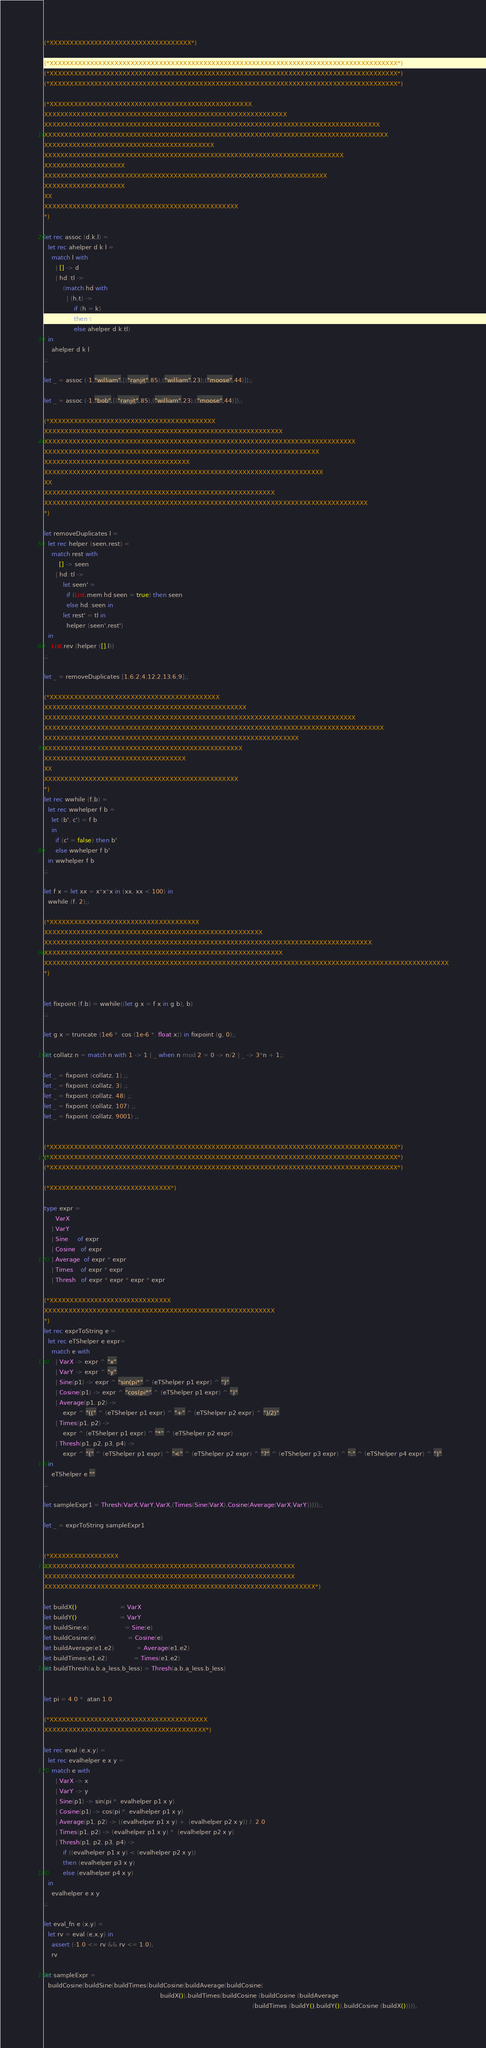Convert code to text. <code><loc_0><loc_0><loc_500><loc_500><_OCaml_>(*XXXXXXXXXXXXXXXXXXXXXXXXXXXXXXXXXXX*)

(*XXXXXXXXXXXXXXXXXXXXXXXXXXXXXXXXXXXXXXXXXXXXXXXXXXXXXXXXXXXXXXXXXXXXXXXXXXXXXXXXXXXXXX*)
(*XXXXXXXXXXXXXXXXXXXXXXXXXXXXXXXXXXXXXXXXXXXXXXXXXXXXXXXXXXXXXXXXXXXXXXXXXXXXXXXXXXXXXX*)
(*XXXXXXXXXXXXXXXXXXXXXXXXXXXXXXXXXXXXXXXXXXXXXXXXXXXXXXXXXXXXXXXXXXXXXXXXXXXXXXXXXXXXXX*)

(*XXXXXXXXXXXXXXXXXXXXXXXXXXXXXXXXXXXXXXXXXXXXXXXXXX
XXXXXXXXXXXXXXXXXXXXXXXXXXXXXXXXXXXXXXXXXXXXXXXXXXXXXXXXXXXX
XXXXXXXXXXXXXXXXXXXXXXXXXXXXXXXXXXXXXXXXXXXXXXXXXXXXXXXXXXXXXXXXXXXXXXXXXXXXXXXXXXX
XXXXXXXXXXXXXXXXXXXXXXXXXXXXXXXXXXXXXXXXXXXXXXXXXXXXXXXXXXXXXXXXXXXXXXXXXXXXXXXXXXXXX
XXXXXXXXXXXXXXXXXXXXXXXXXXXXXXXXXXXXXXXXXX
XXXXXXXXXXXXXXXXXXXXXXXXXXXXXXXXXXXXXXXXXXXXXXXXXXXXXXXXXXXXXXXXXXXXXXXXXX
XXXXXXXXXXXXXXXXXXXX
XXXXXXXXXXXXXXXXXXXXXXXXXXXXXXXXXXXXXXXXXXXXXXXXXXXXXXXXXXXXXXXXXXXXXX
XXXXXXXXXXXXXXXXXXXX
XX
XXXXXXXXXXXXXXXXXXXXXXXXXXXXXXXXXXXXXXXXXXXXXXXX
*)

let rec assoc (d,k,l) =
  let rec ahelper d k l = 
    match l with
      | [] -> d
      | hd::tl ->
          (match hd with
            | (h,t) ->
                if (h = k)
                then t
                else ahelper d k tl)
  in
    ahelper d k l
;;

let _ = assoc (-1,"william",[("ranjit",85);("william",23);("moose",44)]);;    

let _ = assoc (-1,"bob",[("ranjit",85);("william",23);("moose",44)]);;

(*XXXXXXXXXXXXXXXXXXXXXXXXXXXXXXXXXXXXXXXXX
XXXXXXXXXXXXXXXXXXXXXXXXXXXXXXXXXXXXXXXXXXXXXXXXXXXXXXXXXXX
XXXXXXXXXXXXXXXXXXXXXXXXXXXXXXXXXXXXXXXXXXXXXXXXXXXXXXXXXXXXXXXXXXXXXXXXXXXXX
XXXXXXXXXXXXXXXXXXXXXXXXXXXXXXXXXXXXXXXXXXXXXXXXXXXXXXXXXXXXXXXXXXXX
XXXXXXXXXXXXXXXXXXXXXXXXXXXXXXXXXXXX
XXXXXXXXXXXXXXXXXXXXXXXXXXXXXXXXXXXXXXXXXXXXXXXXXXXXXXXXXXXXXXXXXXXXX
XX
XXXXXXXXXXXXXXXXXXXXXXXXXXXXXXXXXXXXXXXXXXXXXXXXXXXXXXXXX
XXXXXXXXXXXXXXXXXXXXXXXXXXXXXXXXXXXXXXXXXXXXXXXXXXXXXXXXXXXXXXXXXXXXXXXXXXXXXXXX
*)

let removeDuplicates l = 
  let rec helper (seen,rest) = 
    match rest with 
        [] -> seen
      | hd::tl -> 
          let seen' = 
            if (List.mem hd seen = true) then seen
            else hd::seen in
          let rest' = tl in 
            helper (seen',rest') 
  in
    List.rev (helper ([],l))
;;

let _ = removeDuplicates [1;6;2;4;12;2;13;6;9];;

(*XXXXXXXXXXXXXXXXXXXXXXXXXXXXXXXXXXXXXXXXXX
XXXXXXXXXXXXXXXXXXXXXXXXXXXXXXXXXXXXXXXXXXXXXXXXXX
XXXXXXXXXXXXXXXXXXXXXXXXXXXXXXXXXXXXXXXXXXXXXXXXXXXXXXXXXXXXXXXXXXXXXXXXXXXXX
XXXXXXXXXXXXXXXXXXXXXXXXXXXXXXXXXXXXXXXXXXXXXXXXXXXXXXXXXXXXXXXXXXXXXXXXXXXXXXXXXXXX
XXXXXXXXXXXXXXXXXXXXXXXXXXXXXXXXXXXXXXXXXXXXXXXXXXXXXXXXXXXXXXX
XXXXXXXXXXXXXXXXXXXXXXXXXXXXXXXXXXXXXXXXXXXXXXXXX
XXXXXXXXXXXXXXXXXXXXXXXXXXXXXXXXXXX
XX
XXXXXXXXXXXXXXXXXXXXXXXXXXXXXXXXXXXXXXXXXXXXXXXX
*)
let rec wwhile (f,b) =
  let rec wwhelper f b =
    let (b', c') = f b 
    in
      if (c' = false) then b'
      else wwhelper f b'
  in wwhelper f b
;;

let f x = let xx = x*x*x in (xx, xx < 100) in
  wwhile (f, 2);;

(*XXXXXXXXXXXXXXXXXXXXXXXXXXXXXXXXXXXXX
XXXXXXXXXXXXXXXXXXXXXXXXXXXXXXXXXXXXXXXXXXXXXXXXXXXXXX
XXXXXXXXXXXXXXXXXXXXXXXXXXXXXXXXXXXXXXXXXXXXXXXXXXXXXXXXXXXXXXXXXXXXXXXXXXXXXXXXX
XXXXXXXXXXXXXXXXXXXXXXXXXXXXXXXXXXXXXXXXXXXXXXXXXXXXXXXXXXX
XXXXXXXXXXXXXXXXXXXXXXXXXXXXXXXXXXXXXXXXXXXXXXXXXXXXXXXXXXXXXXXXXXXXXXXXXXXXXXXXXXXXXXXXXXXXXXXXXXXX
*)


let fixpoint (f,b) = wwhile((let g x = f x in g b), b)
;;

let g x = truncate (1e6 *. cos (1e-6 *. float x)) in fixpoint (g, 0);; 

let collatz n = match n with 1 -> 1 | _ when n mod 2 = 0 -> n/2 | _ -> 3*n + 1;;

let _ = fixpoint (collatz, 1) ;;
let _ = fixpoint (collatz, 3) ;;
let _ = fixpoint (collatz, 48) ;;
let _ = fixpoint (collatz, 107) ;;
let _ = fixpoint (collatz, 9001) ;;


(*XXXXXXXXXXXXXXXXXXXXXXXXXXXXXXXXXXXXXXXXXXXXXXXXXXXXXXXXXXXXXXXXXXXXXXXXXXXXXXXXXXXXXX*)
(*XXXXXXXXXXXXXXXXXXXXXXXXXXXXXXXXXXXXXXXXXXXXXXXXXXXXXXXXXXXXXXXXXXXXXXXXXXXXXXXXXXXXXX*)
(*XXXXXXXXXXXXXXXXXXXXXXXXXXXXXXXXXXXXXXXXXXXXXXXXXXXXXXXXXXXXXXXXXXXXXXXXXXXXXXXXXXXXXX*)

(*XXXXXXXXXXXXXXXXXXXXXXXXXXXXXX*) 

type expr = 
      VarX
    | VarY
    | Sine     of expr
    | Cosine   of expr
    | Average  of expr * expr
    | Times    of expr * expr
    | Thresh   of expr * expr * expr * expr	

(*XXXXXXXXXXXXXXXXXXXXXXXXXXXXXX
XXXXXXXXXXXXXXXXXXXXXXXXXXXXXXXXXXXXXXXXXXXXXXXXXXXXXXXXX
*)
let rec exprToString e =
  let rec eTShelper e expr=
    match e with
      | VarX -> expr ^ "x"
      | VarY -> expr ^ "y"
      | Sine(p1) -> expr ^ "sin(pi*" ^ (eTShelper p1 expr) ^ ")" 
      | Cosine(p1) -> expr ^ "cos(pi*" ^ (eTShelper p1 expr) ^ ")"
      | Average(p1, p2) -> 
          expr ^ "((" ^ (eTShelper p1 expr) ^ "+" ^ (eTShelper p2 expr) ^ ")/2)"
      | Times(p1, p2) ->
          expr ^ (eTShelper p1 expr) ^ "*" ^ (eTShelper p2 expr)
      | Thresh(p1, p2, p3, p4) ->
          expr ^ "(" ^ (eTShelper p1 expr) ^ "<" ^ (eTShelper p2 expr) ^ "?" ^ (eTShelper p3 expr) ^ ":" ^ (eTShelper p4 expr) ^ ")"
  in
    eTShelper e ""
;;

let sampleExpr1 = Thresh(VarX,VarY,VarX,(Times(Sine(VarX),Cosine(Average(VarX,VarY)))));;

let _ = exprToString sampleExpr1 


(*XXXXXXXXXXXXXXXXX
XXXXXXXXXXXXXXXXXXXXXXXXXXXXXXXXXXXXXXXXXXXXXXXXXXXXXXXXXXXXXX
XXXXXXXXXXXXXXXXXXXXXXXXXXXXXXXXXXXXXXXXXXXXXXXXXXXXXXXXXXXXXX
XXXXXXXXXXXXXXXXXXXXXXXXXXXXXXXXXXXXXXXXXXXXXXXXXXXXXXXXXXXXXXXXXXX*)

let buildX()                       = VarX
let buildY()                       = VarY
let buildSine(e)                   = Sine(e)
let buildCosine(e)                 = Cosine(e)
let buildAverage(e1,e2)            = Average(e1,e2)
let buildTimes(e1,e2)              = Times(e1,e2)
let buildThresh(a,b,a_less,b_less) = Thresh(a,b,a_less,b_less)


let pi = 4.0 *. atan 1.0

(*XXXXXXXXXXXXXXXXXXXXXXXXXXXXXXXXXXXXXXX
XXXXXXXXXXXXXXXXXXXXXXXXXXXXXXXXXXXXXXXX*)

let rec eval (e,x,y) =
  let rec evalhelper e x y =
    match e with
      | VarX -> x
      | VarY -> y
      | Sine(p1) -> sin(pi *. evalhelper p1 x y)
      | Cosine(p1) -> cos(pi *. evalhelper p1 x y)
      | Average(p1, p2) -> ((evalhelper p1 x y) +. (evalhelper p2 x y)) /. 2.0
      | Times(p1, p2) -> (evalhelper p1 x y) *. (evalhelper p2 x y)
      | Thresh(p1, p2, p3, p4) ->
          if ((evalhelper p1 x y) < (evalhelper p2 x y))
          then (evalhelper p3 x y)
          else (evalhelper p4 x y)
  in
    evalhelper e x y
;;

let eval_fn e (x,y) = 
  let rv = eval (e,x,y) in
    assert (-1.0 <= rv && rv <= 1.0);
    rv

let sampleExpr =
  buildCosine(buildSine(buildTimes(buildCosine(buildAverage(buildCosine(
                                                              buildX()),buildTimes(buildCosine (buildCosine (buildAverage
                                                                                                               (buildTimes (buildY(),buildY()),buildCosine (buildX())))),</code> 